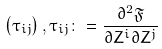Convert formula to latex. <formula><loc_0><loc_0><loc_500><loc_500>\left ( \tau _ { i j } \right ) , \tau _ { i j } \colon = \frac { \partial ^ { 2 } \mathfrak { F } } { \partial Z ^ { i } \partial Z ^ { j } }</formula> 